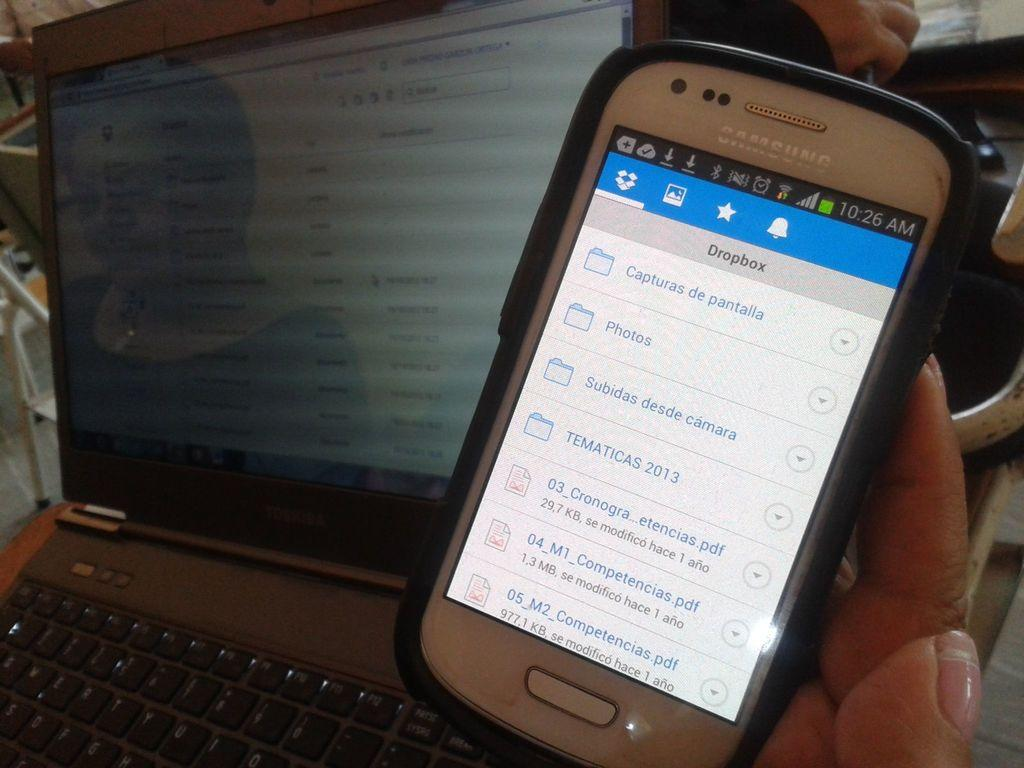<image>
Write a terse but informative summary of the picture. open lap top and mobile phone with documents in PDF on display page 